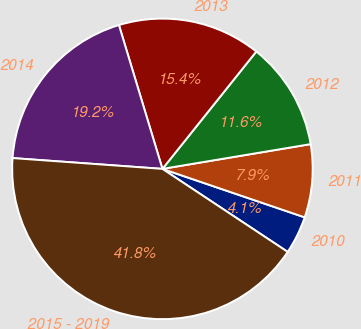Convert chart to OTSL. <chart><loc_0><loc_0><loc_500><loc_500><pie_chart><fcel>2010<fcel>2011<fcel>2012<fcel>2013<fcel>2014<fcel>2015 - 2019<nl><fcel>4.09%<fcel>7.86%<fcel>11.63%<fcel>15.41%<fcel>19.18%<fcel>41.83%<nl></chart> 